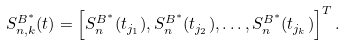<formula> <loc_0><loc_0><loc_500><loc_500>S ^ { B ^ { * } } _ { n , k } ( t ) = \left [ S _ { n } ^ { B ^ { * } } ( t _ { j _ { 1 } } ) , S _ { n } ^ { B ^ { * } } ( t _ { j _ { 2 } } ) , \dots , S _ { n } ^ { B ^ { * } } ( t _ { j _ { k } } ) \right ] ^ { T } .</formula> 